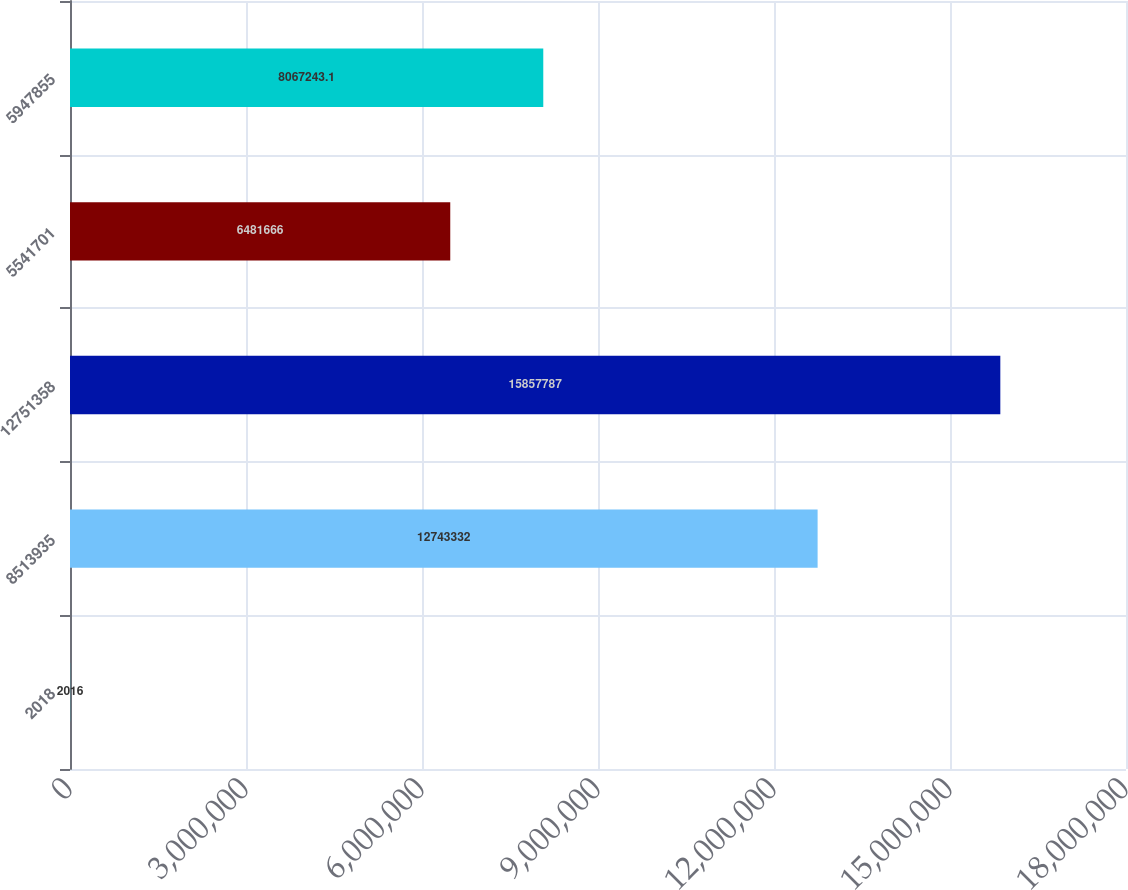Convert chart to OTSL. <chart><loc_0><loc_0><loc_500><loc_500><bar_chart><fcel>2018<fcel>8513935<fcel>12751358<fcel>5541701<fcel>5947855<nl><fcel>2016<fcel>1.27433e+07<fcel>1.58578e+07<fcel>6.48167e+06<fcel>8.06724e+06<nl></chart> 